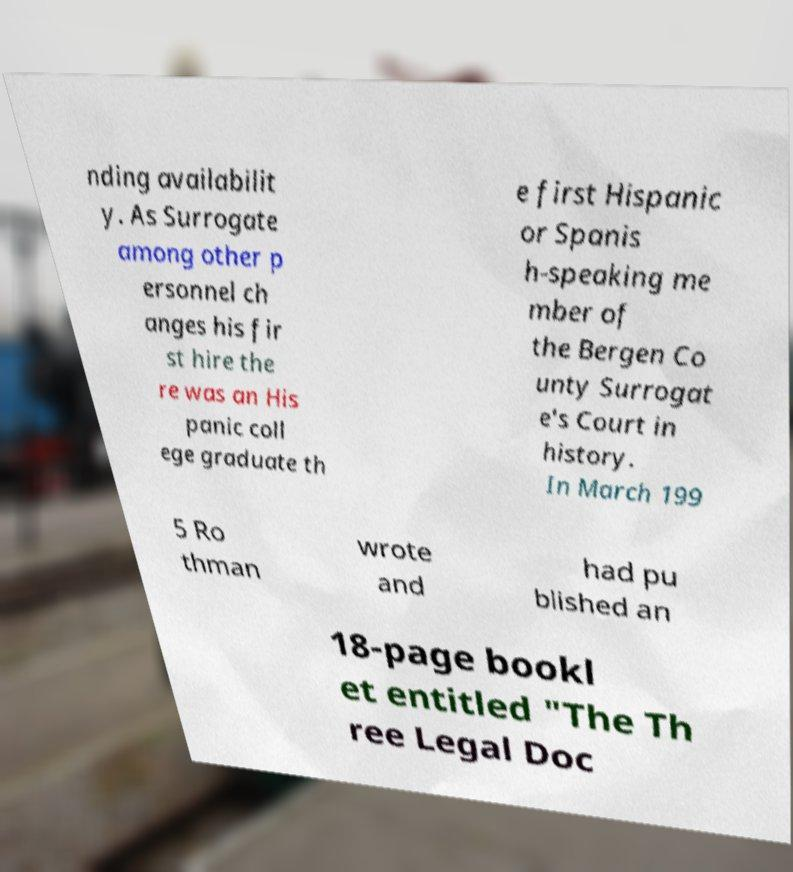Please read and relay the text visible in this image. What does it say? nding availabilit y. As Surrogate among other p ersonnel ch anges his fir st hire the re was an His panic coll ege graduate th e first Hispanic or Spanis h-speaking me mber of the Bergen Co unty Surrogat e's Court in history. In March 199 5 Ro thman wrote and had pu blished an 18-page bookl et entitled "The Th ree Legal Doc 